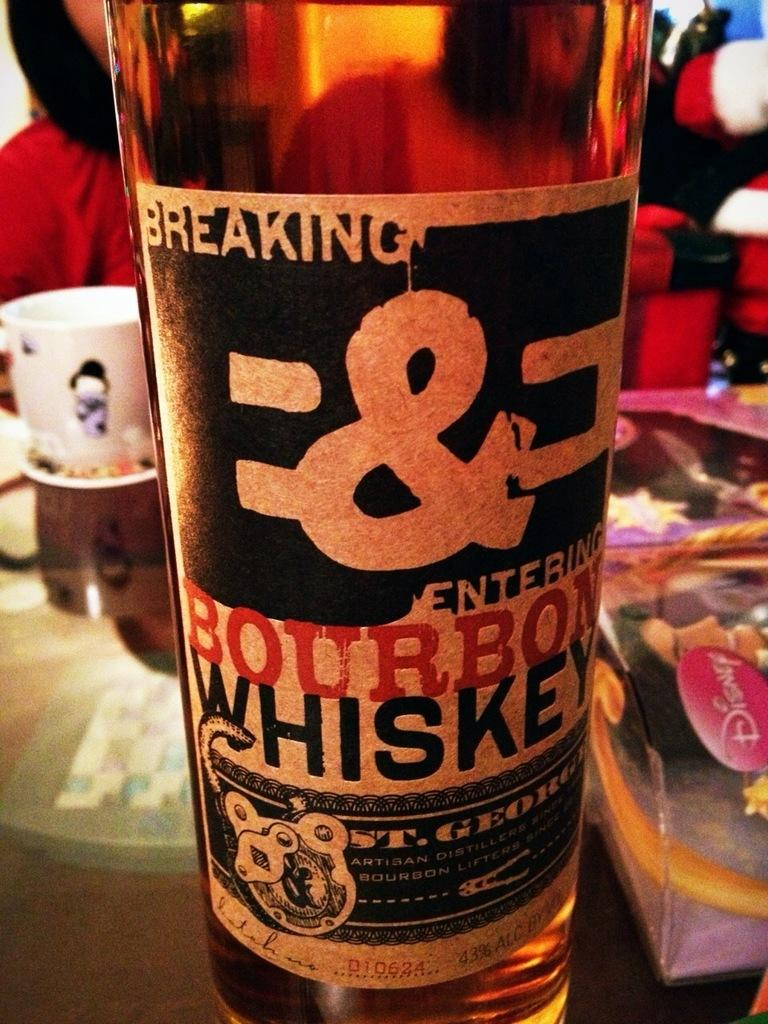Provide a one-sentence caption for the provided image. A bottle of B&E Bourbon Whiskey is on a table by a Disney toy. 